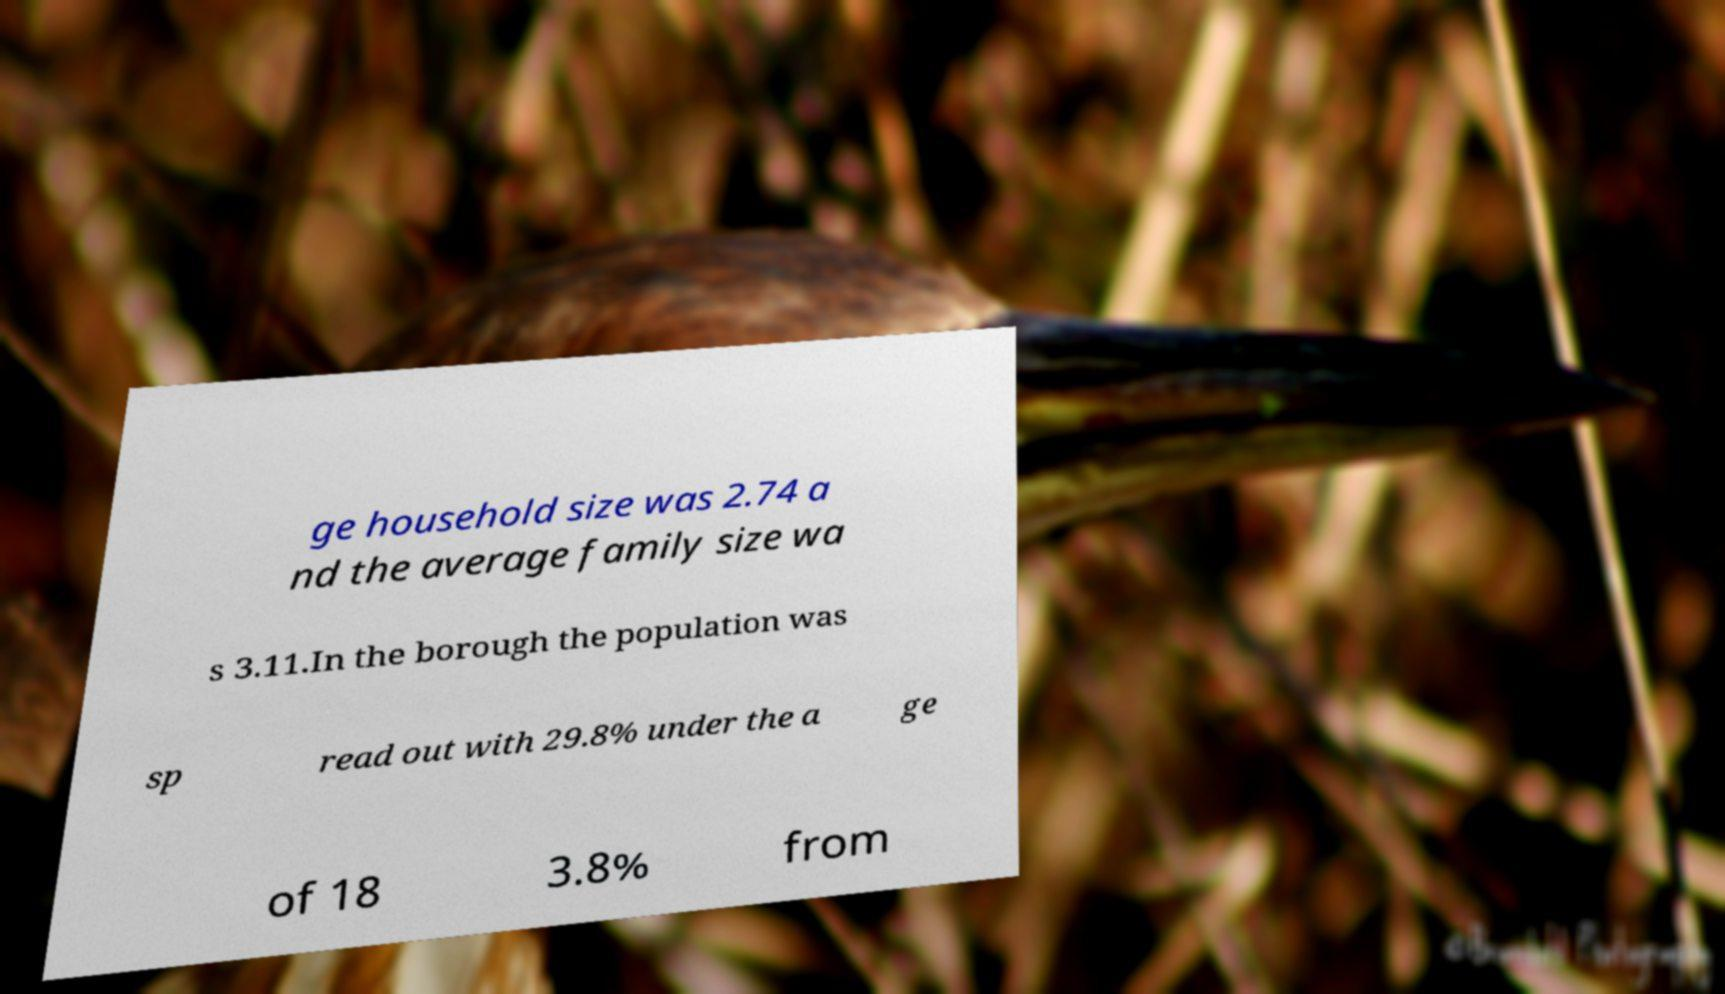I need the written content from this picture converted into text. Can you do that? ge household size was 2.74 a nd the average family size wa s 3.11.In the borough the population was sp read out with 29.8% under the a ge of 18 3.8% from 